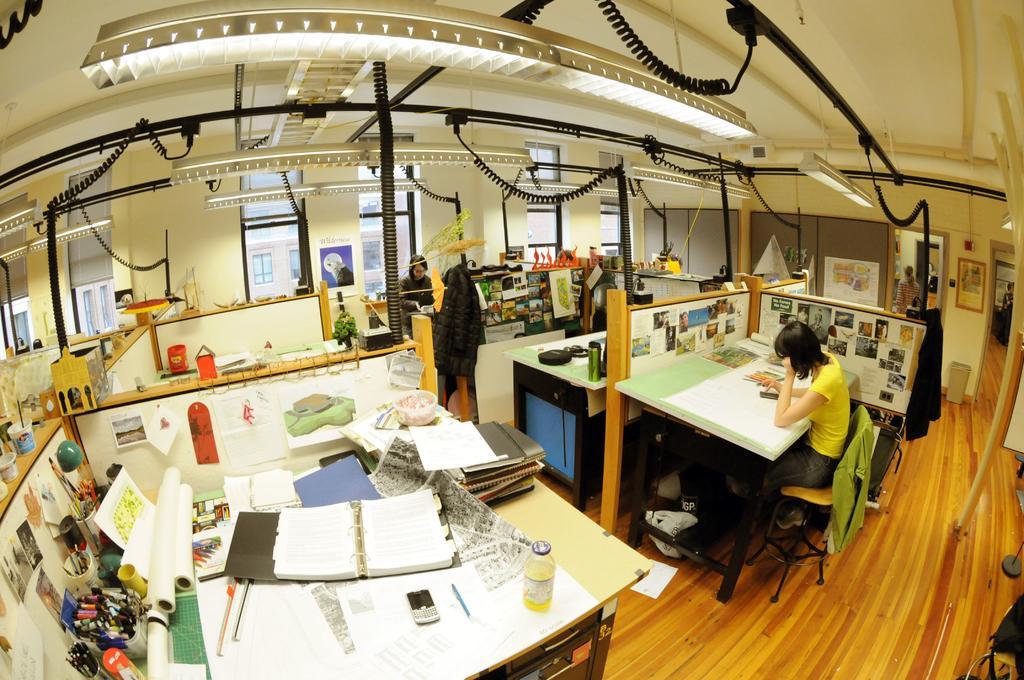In one or two sentences, can you explain what this image depicts? In this picture we can see a person wearing yellow t-shirt is sitting on a chair. On the table we can see bottle, files, mobile and few other objects. On the right side of the picture we can see a frame on the wall. This is a floor at the bottom portion of the picture. We can see people in this picture. 